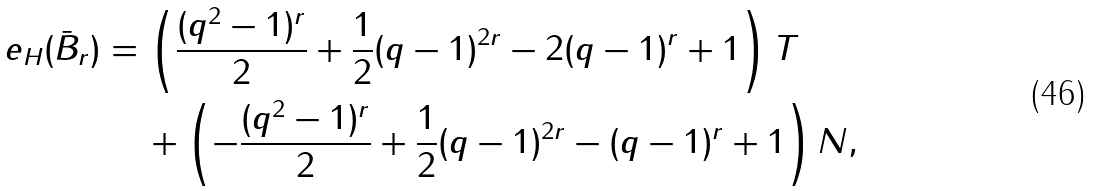Convert formula to latex. <formula><loc_0><loc_0><loc_500><loc_500>e _ { H } ( \bar { B } _ { r } ) = \, & \left ( \frac { ( q ^ { 2 } - 1 ) ^ { r } } 2 + \frac { 1 } { 2 } ( q - 1 ) ^ { 2 r } - 2 ( q - 1 ) ^ { r } + 1 \right ) T \\ & + \left ( - \frac { ( q ^ { 2 } - 1 ) ^ { r } } 2 + \frac { 1 } { 2 } ( q - 1 ) ^ { 2 r } - ( q - 1 ) ^ { r } + 1 \right ) N ,</formula> 